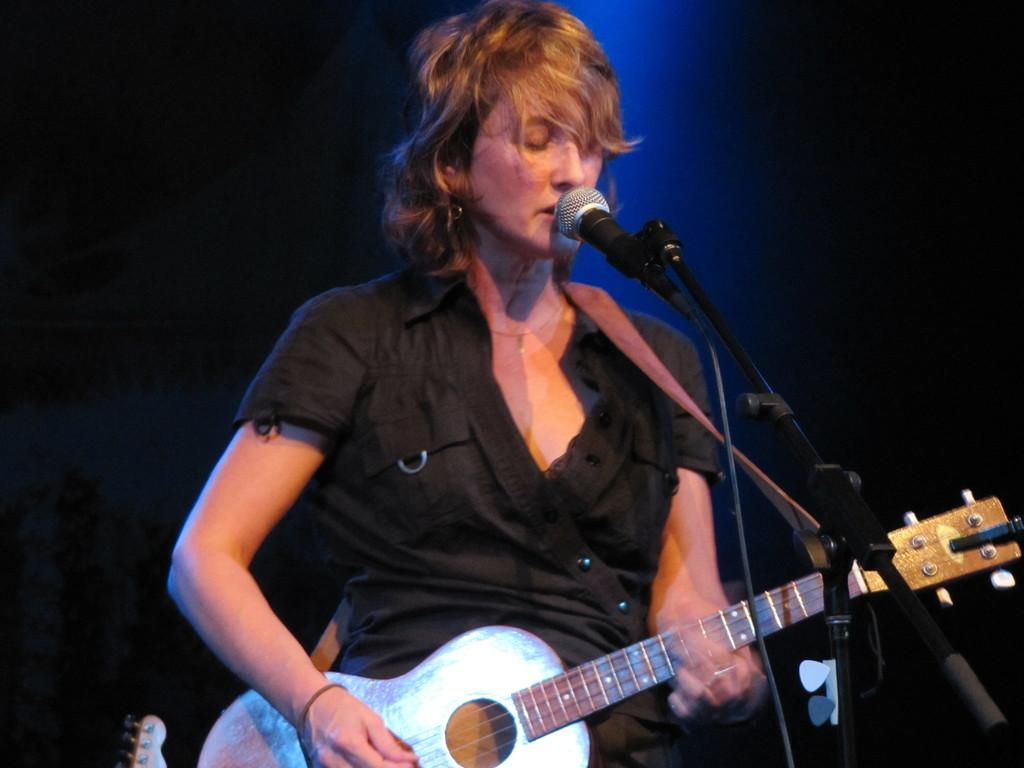What is the main subject of the image? The main subject of the image is a woman. What is the woman holding in her hand? The woman is holding a guitar in her hand. What type of substance is the woman using to make her arm glow in the image? There is no indication in the image that the woman's arm is glowing or that any substance is being used for that purpose. 